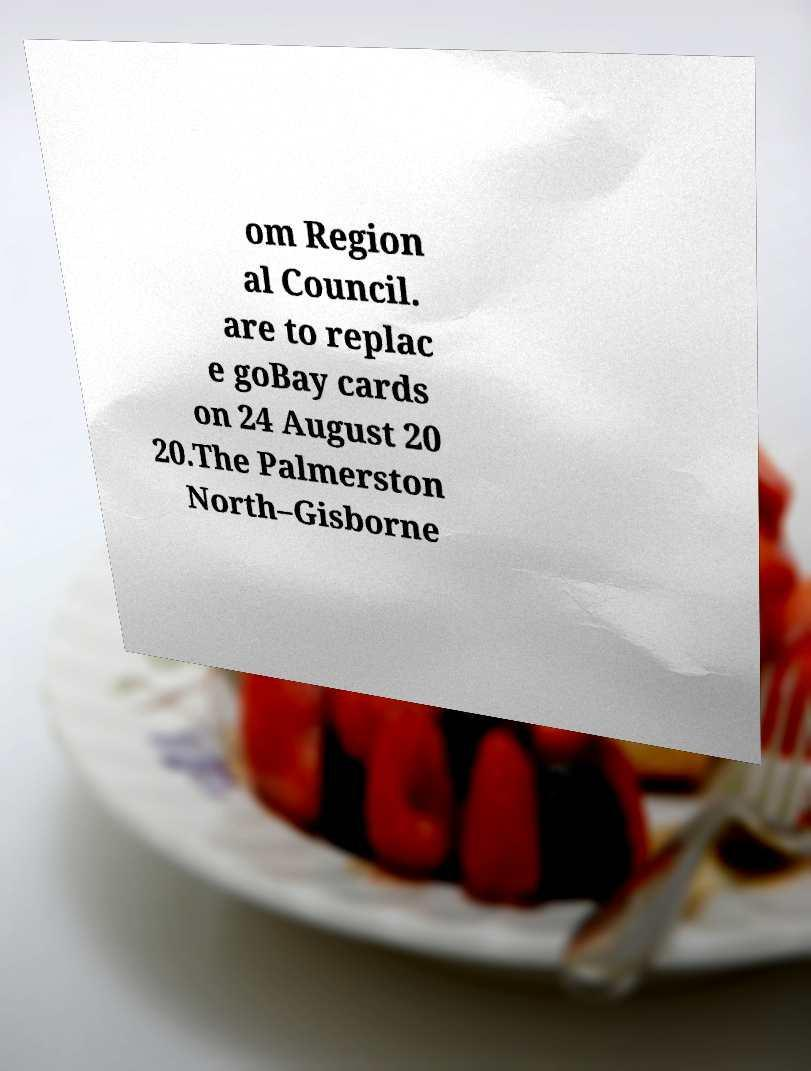Can you read and provide the text displayed in the image?This photo seems to have some interesting text. Can you extract and type it out for me? om Region al Council. are to replac e goBay cards on 24 August 20 20.The Palmerston North–Gisborne 